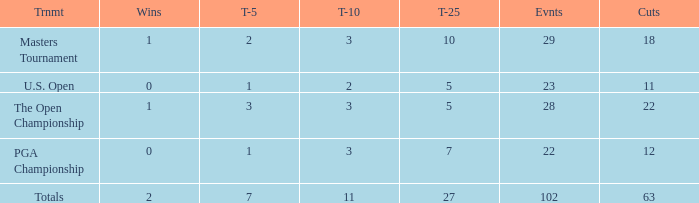How many top 10s when he had under 1 top 5s? None. 